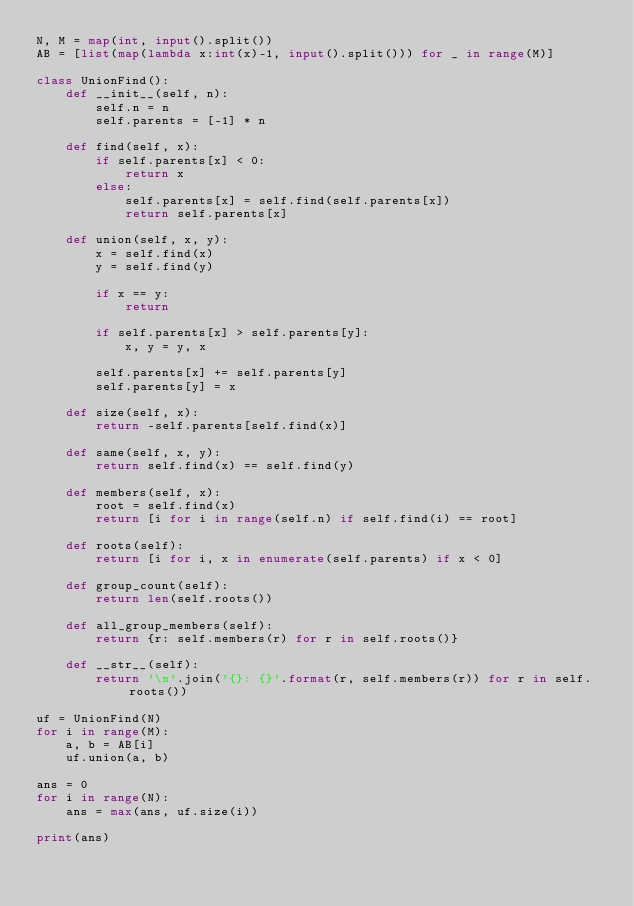<code> <loc_0><loc_0><loc_500><loc_500><_Python_>N, M = map(int, input().split())
AB = [list(map(lambda x:int(x)-1, input().split())) for _ in range(M)]

class UnionFind():
    def __init__(self, n):
        self.n = n
        self.parents = [-1] * n

    def find(self, x):
        if self.parents[x] < 0:
            return x
        else:
            self.parents[x] = self.find(self.parents[x])
            return self.parents[x]

    def union(self, x, y):
        x = self.find(x)
        y = self.find(y)

        if x == y:
            return

        if self.parents[x] > self.parents[y]:
            x, y = y, x

        self.parents[x] += self.parents[y]
        self.parents[y] = x

    def size(self, x):
        return -self.parents[self.find(x)]

    def same(self, x, y):
        return self.find(x) == self.find(y)

    def members(self, x):
        root = self.find(x)
        return [i for i in range(self.n) if self.find(i) == root]

    def roots(self):
        return [i for i, x in enumerate(self.parents) if x < 0]

    def group_count(self):
        return len(self.roots())

    def all_group_members(self):
        return {r: self.members(r) for r in self.roots()}

    def __str__(self):
        return '\n'.join('{}: {}'.format(r, self.members(r)) for r in self.roots())

uf = UnionFind(N)
for i in range(M):
    a, b = AB[i]
    uf.union(a, b)

ans = 0
for i in range(N):
    ans = max(ans, uf.size(i))

print(ans)</code> 